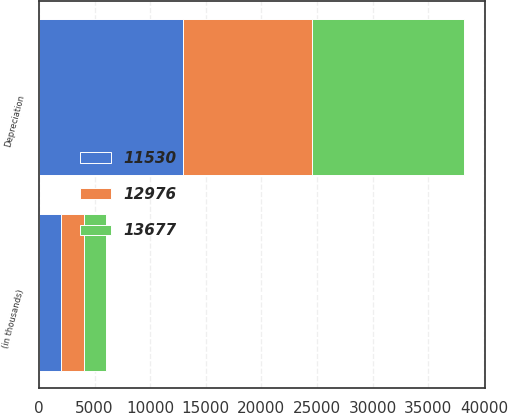Convert chart to OTSL. <chart><loc_0><loc_0><loc_500><loc_500><stacked_bar_chart><ecel><fcel>(in thousands)<fcel>Depreciation<nl><fcel>13677<fcel>2007<fcel>13677<nl><fcel>11530<fcel>2006<fcel>12976<nl><fcel>12976<fcel>2005<fcel>11530<nl></chart> 